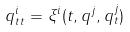Convert formula to latex. <formula><loc_0><loc_0><loc_500><loc_500>q _ { t t } ^ { i } = \xi ^ { i } ( t , q ^ { j } , q _ { t } ^ { j } )</formula> 